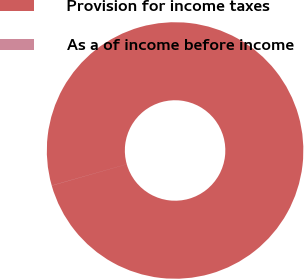<chart> <loc_0><loc_0><loc_500><loc_500><pie_chart><fcel>Provision for income taxes<fcel>As a of income before income<nl><fcel>99.99%<fcel>0.01%<nl></chart> 